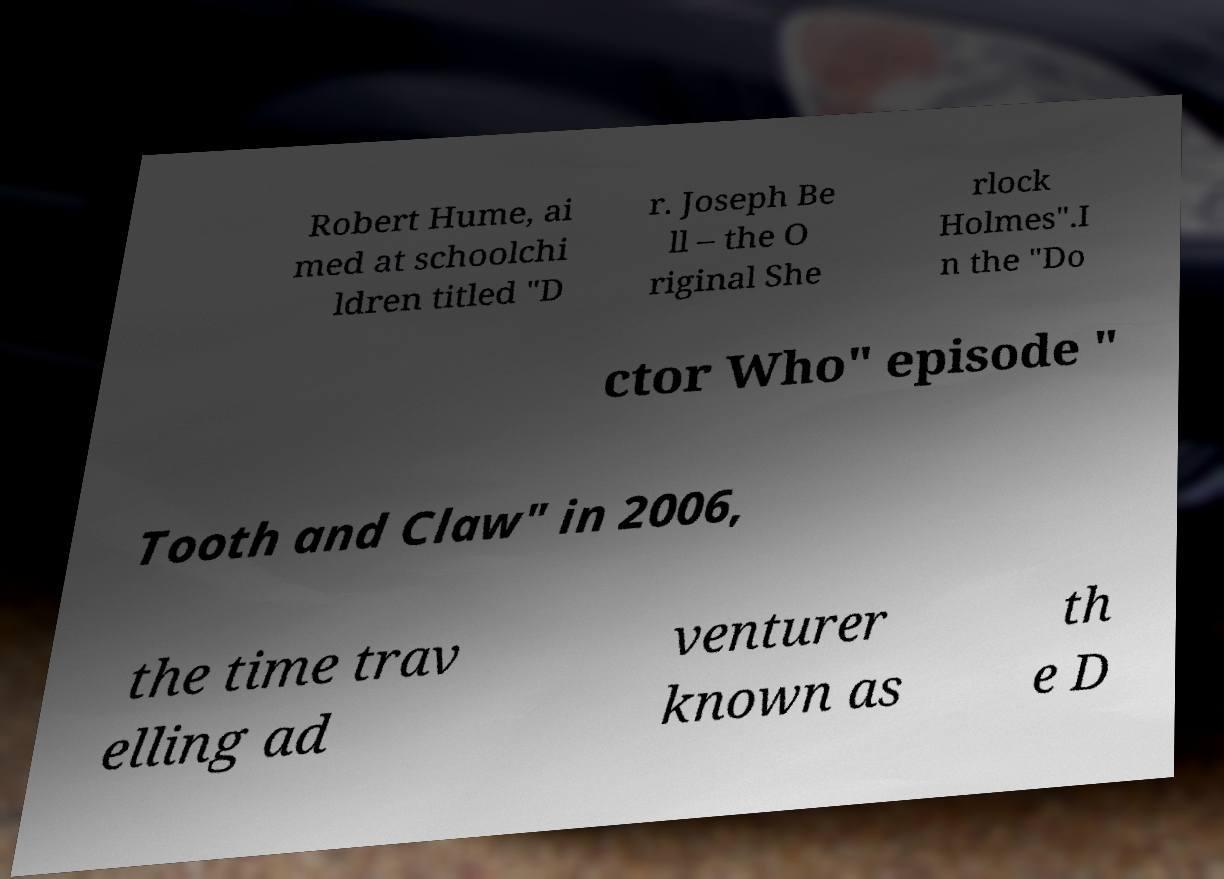Could you extract and type out the text from this image? Robert Hume, ai med at schoolchi ldren titled "D r. Joseph Be ll – the O riginal She rlock Holmes".I n the "Do ctor Who" episode " Tooth and Claw" in 2006, the time trav elling ad venturer known as th e D 